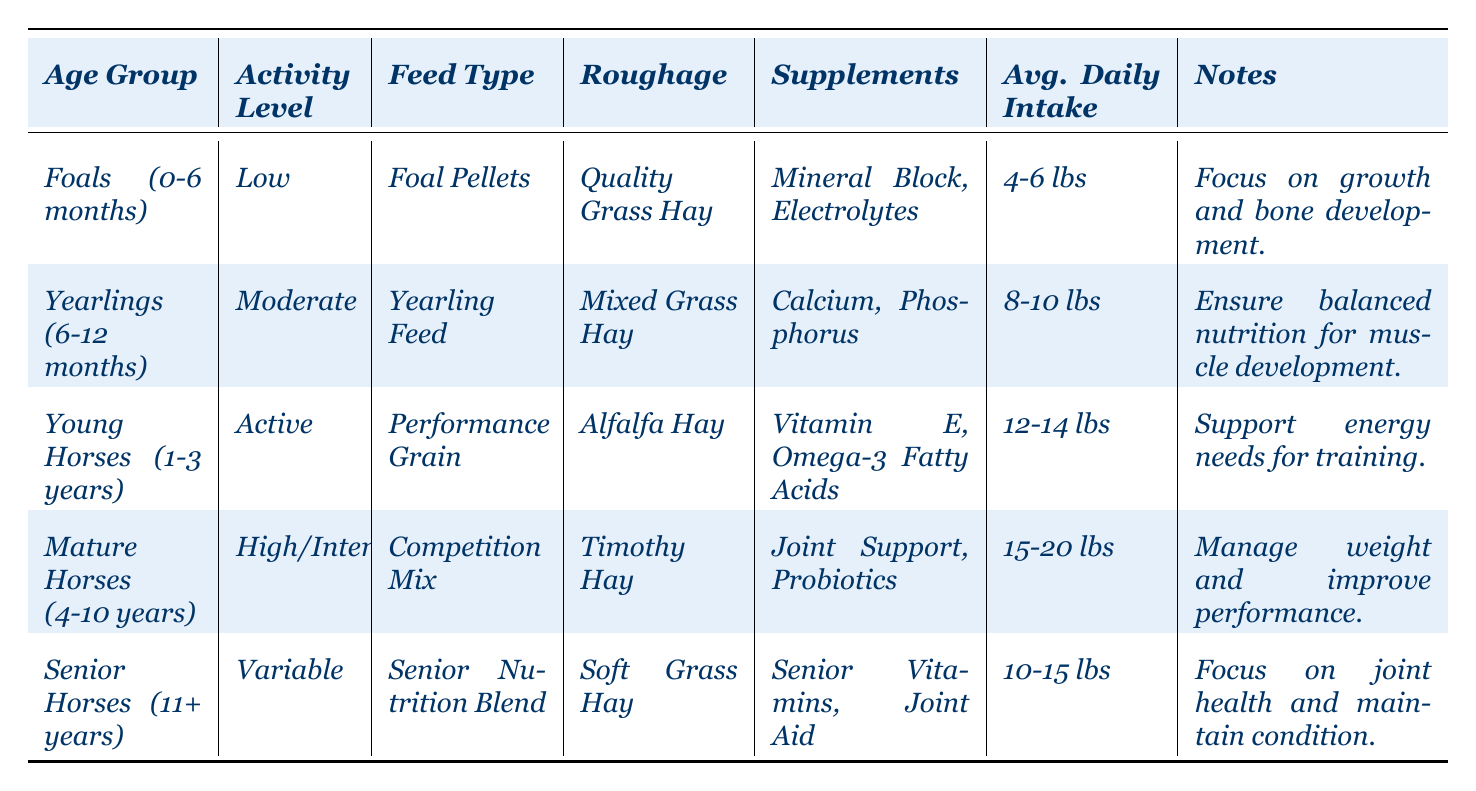What type of feed is recommended for yearlings? The table lists "Yearling Feed" as the feed type specifically recommended for the age group of yearlings (6-12 months).
Answer: Yearling Feed What is the average daily intake for mature horses? According to the table, the average daily intake for mature horses (4-10 years) is stated as 15-20 lbs.
Answer: 15-20 lbs Do foals require supplements for bone development? Yes, the notes for foals (0-6 months) indicate that their nutritional plan includes a "Mineral Block" and "Electrolytes," which support growth and bone development.
Answer: Yes Which age group has an active activity level and what is their roughage? The "Young Horses (1-3 years)" age group is classified as having an active activity level, and their roughage is "Alfalfa Hay."
Answer: Young Horses, Alfalfa Hay Is the average daily intake for senior horses greater than that of foals? No, the average daily intake for senior horses (10-15 lbs) is less than that of foals (4-6 lbs), which makes the statement false.
Answer: No What is the purpose of supplements for mature horses? The table states that for mature horses (4-10 years), supplements include "Joint Support" and "Probiotics," which are intended to manage weight and improve performance.
Answer: Manage weight and improve performance How many total types of supplements are mentioned across all age groups? In summing up the unique supplements listed for each age group — "Mineral Block," "Electrolytes," "Calcium," "Phosphorus," "Vitamin E," "Omega-3 Fatty Acids," "Joint Support," "Probiotics," "Senior Vitamins," and "Joint Aid" — we have a total of 10 unique supplements.
Answer: 10 What is the roughage type for senior horses, and what is its purpose? The roughage for senior horses (11+ years) is "Soft Grass Hay," which supports their digestive health and overall well-being.
Answer: Soft Grass Hay Compare the average daily intake for young horses and mature horses. Young horses have an average daily intake of 12-14 lbs, while mature horses average 15-20 lbs. Mature horses have a higher intake than young horses, indicating their greater energy needs.
Answer: Mature horses have a higher intake Which group has the lowest daily intake, and what is the value? The age group with the lowest average daily intake is foals (0-6 months), with an intake of 4-6 lbs as shown in the table.
Answer: Foals, 4-6 lbs 